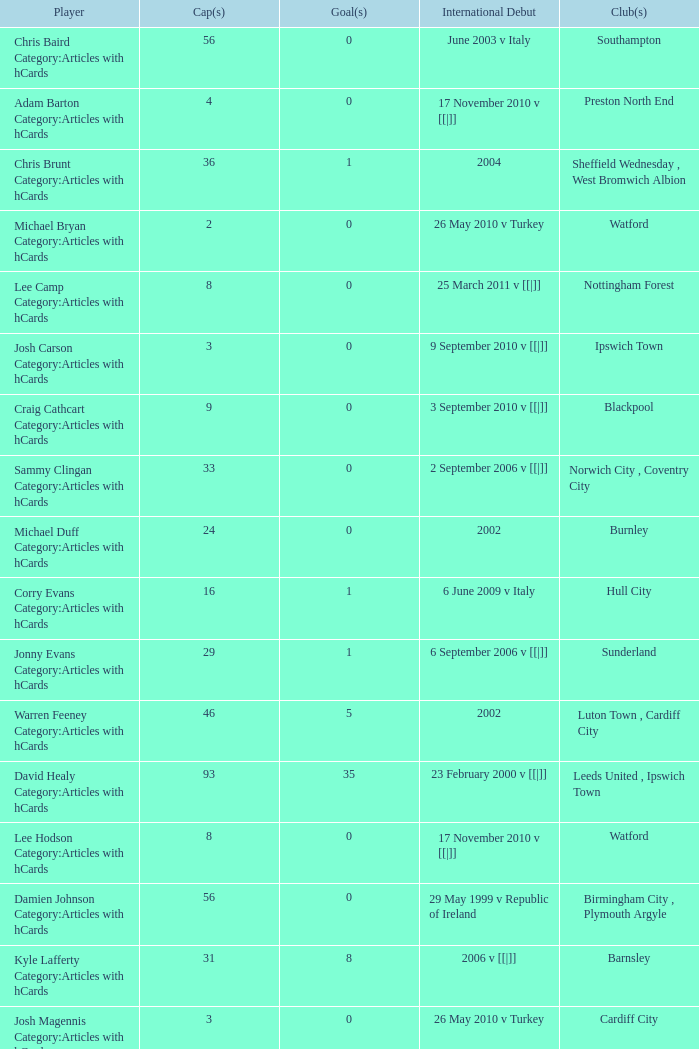How many caps figures are there for Norwich City, Coventry City? 1.0. 